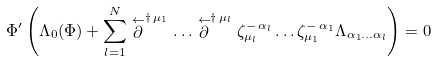<formula> <loc_0><loc_0><loc_500><loc_500>\Phi ^ { \prime } \left ( \Lambda _ { 0 } ( \Phi ) + \sum _ { l = 1 } ^ { N } \stackrel { \leftarrow } { \partial } ^ { \dagger \, \mu _ { 1 } } \dots \stackrel { \leftarrow } { \partial } ^ { \dagger \, \mu _ { l } } \zeta ^ { - \, \alpha _ { l } } _ { \mu _ { l } } \dots \zeta ^ { - \, \alpha _ { 1 } } _ { \mu _ { 1 } } \Lambda _ { \alpha _ { 1 } \dots \alpha _ { l } } \right ) = 0</formula> 